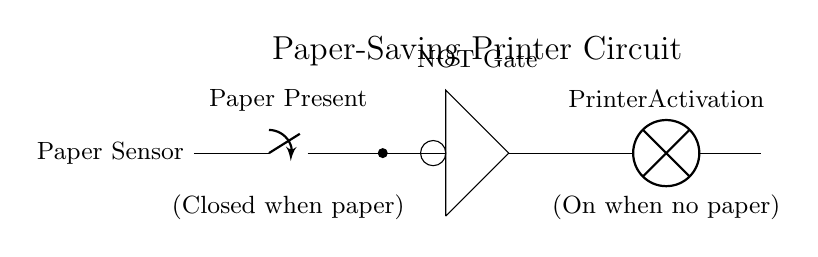What is the primary function of the NOT gate in this circuit? The NOT gate inverts the input signal from the paper sensor. When paper is present (sensor closed), the output of the NOT gate is low (off), preventing printer activation.
Answer: Inversion What does the lamp represent in this circuit? The lamp indicates whether the printer is active. It lights up when the circuit is completed, which happens when there is no paper present, triggering the NOT gate.
Answer: Printer activation How many main components are in the circuit? The circuit contains three main components: the paper sensor, the NOT gate, and the printer activation (lamp).
Answer: Three What happens to the printer when paper is present? When paper is present, the paper sensor is closed, sending a signal to the NOT gate which then outputs a low signal, thus keeping the printer inactive.
Answer: Printer inactive If the paper sensor is open, what is the output of the NOT gate? The NOT gate will produce a high output when the paper sensor is open (no paper present), which triggers the printer activation.
Answer: High output 